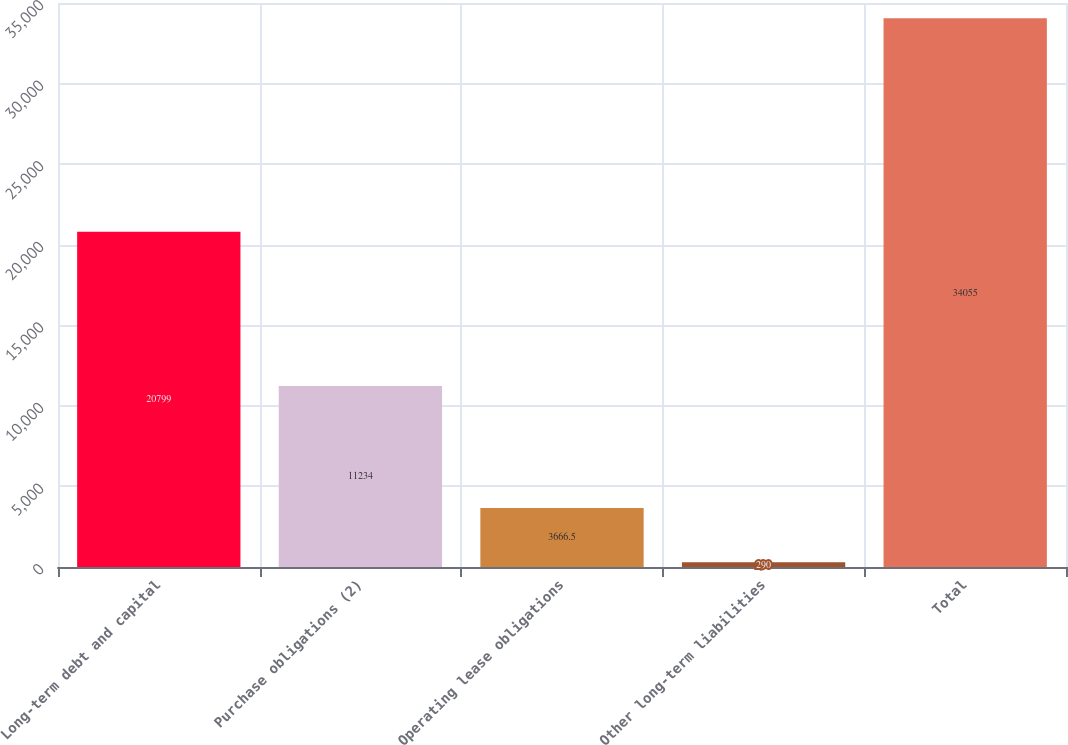Convert chart. <chart><loc_0><loc_0><loc_500><loc_500><bar_chart><fcel>Long-term debt and capital<fcel>Purchase obligations (2)<fcel>Operating lease obligations<fcel>Other long-term liabilities<fcel>Total<nl><fcel>20799<fcel>11234<fcel>3666.5<fcel>290<fcel>34055<nl></chart> 